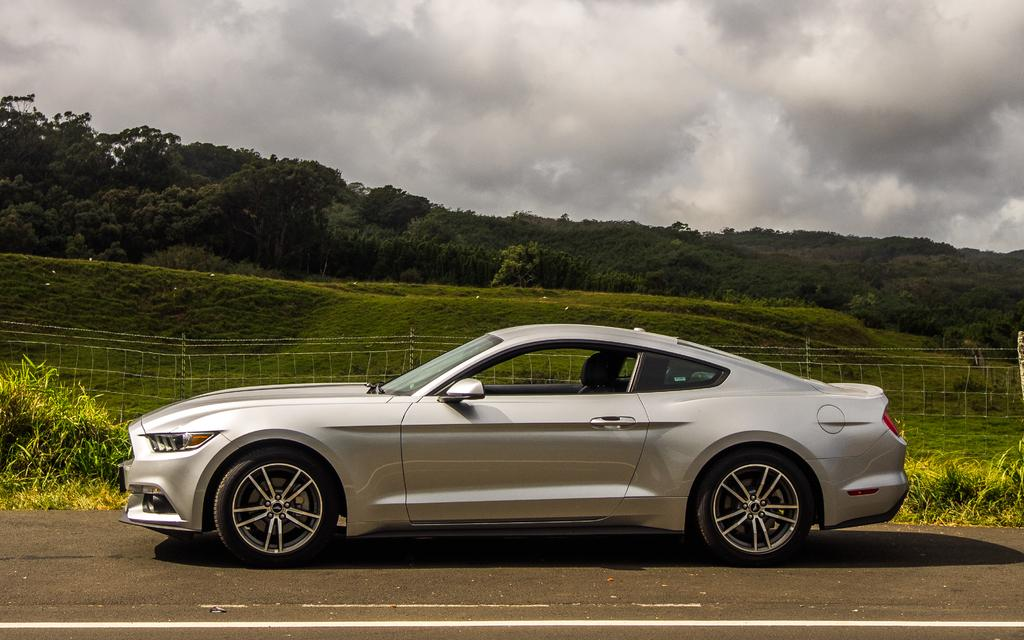What type of vehicle is on the road in the image? There is a car on the road in the image. What type of vegetation can be seen in the image? There is grass, plants, and trees in the image. What is the purpose of the fence in the image? The fence serves as a boundary or barrier in the image. What is visible in the background of the image? The sky is visible in the background of the image, with clouds present. Can you see a snake slithering through the grass in the image? There is no snake present in the image; it only features a car, grass, fence, plants, trees, and a sky with clouds. 